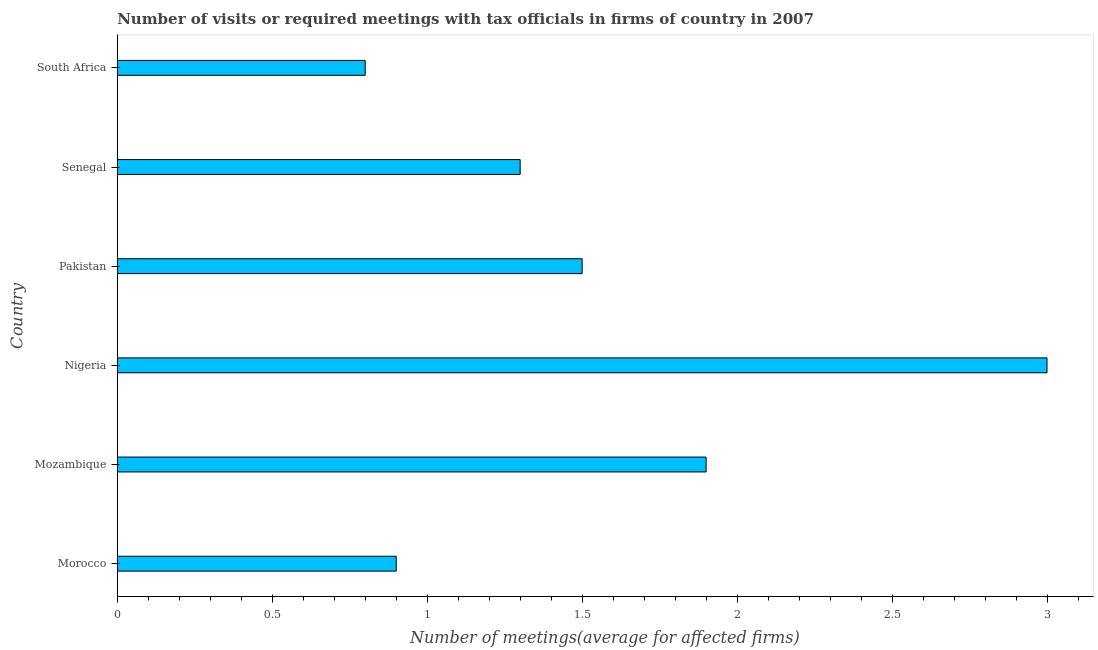Does the graph contain any zero values?
Your answer should be compact. No. Does the graph contain grids?
Provide a succinct answer. No. What is the title of the graph?
Your response must be concise. Number of visits or required meetings with tax officials in firms of country in 2007. What is the label or title of the X-axis?
Provide a succinct answer. Number of meetings(average for affected firms). What is the number of required meetings with tax officials in Morocco?
Give a very brief answer. 0.9. Across all countries, what is the maximum number of required meetings with tax officials?
Your answer should be very brief. 3. In which country was the number of required meetings with tax officials maximum?
Your answer should be compact. Nigeria. In which country was the number of required meetings with tax officials minimum?
Offer a very short reply. South Africa. What is the difference between the number of required meetings with tax officials in Mozambique and Senegal?
Provide a short and direct response. 0.6. What is the average number of required meetings with tax officials per country?
Provide a succinct answer. 1.57. What is the median number of required meetings with tax officials?
Provide a succinct answer. 1.4. In how many countries, is the number of required meetings with tax officials greater than 1.5 ?
Make the answer very short. 2. What is the ratio of the number of required meetings with tax officials in Mozambique to that in Pakistan?
Offer a terse response. 1.27. Is the number of required meetings with tax officials in Mozambique less than that in Pakistan?
Keep it short and to the point. No. In how many countries, is the number of required meetings with tax officials greater than the average number of required meetings with tax officials taken over all countries?
Offer a very short reply. 2. Are all the bars in the graph horizontal?
Make the answer very short. Yes. How many countries are there in the graph?
Ensure brevity in your answer.  6. What is the difference between two consecutive major ticks on the X-axis?
Offer a very short reply. 0.5. What is the Number of meetings(average for affected firms) in Pakistan?
Offer a terse response. 1.5. What is the Number of meetings(average for affected firms) in South Africa?
Ensure brevity in your answer.  0.8. What is the difference between the Number of meetings(average for affected firms) in Morocco and Nigeria?
Your answer should be very brief. -2.1. What is the difference between the Number of meetings(average for affected firms) in Morocco and Pakistan?
Make the answer very short. -0.6. What is the difference between the Number of meetings(average for affected firms) in Morocco and Senegal?
Keep it short and to the point. -0.4. What is the difference between the Number of meetings(average for affected firms) in Mozambique and Nigeria?
Keep it short and to the point. -1.1. What is the difference between the Number of meetings(average for affected firms) in Mozambique and South Africa?
Keep it short and to the point. 1.1. What is the difference between the Number of meetings(average for affected firms) in Nigeria and Pakistan?
Provide a short and direct response. 1.5. What is the difference between the Number of meetings(average for affected firms) in Nigeria and Senegal?
Give a very brief answer. 1.7. What is the difference between the Number of meetings(average for affected firms) in Senegal and South Africa?
Ensure brevity in your answer.  0.5. What is the ratio of the Number of meetings(average for affected firms) in Morocco to that in Mozambique?
Your answer should be very brief. 0.47. What is the ratio of the Number of meetings(average for affected firms) in Morocco to that in Nigeria?
Your response must be concise. 0.3. What is the ratio of the Number of meetings(average for affected firms) in Morocco to that in Senegal?
Give a very brief answer. 0.69. What is the ratio of the Number of meetings(average for affected firms) in Morocco to that in South Africa?
Make the answer very short. 1.12. What is the ratio of the Number of meetings(average for affected firms) in Mozambique to that in Nigeria?
Keep it short and to the point. 0.63. What is the ratio of the Number of meetings(average for affected firms) in Mozambique to that in Pakistan?
Give a very brief answer. 1.27. What is the ratio of the Number of meetings(average for affected firms) in Mozambique to that in Senegal?
Keep it short and to the point. 1.46. What is the ratio of the Number of meetings(average for affected firms) in Mozambique to that in South Africa?
Give a very brief answer. 2.38. What is the ratio of the Number of meetings(average for affected firms) in Nigeria to that in Pakistan?
Provide a succinct answer. 2. What is the ratio of the Number of meetings(average for affected firms) in Nigeria to that in Senegal?
Your answer should be very brief. 2.31. What is the ratio of the Number of meetings(average for affected firms) in Nigeria to that in South Africa?
Make the answer very short. 3.75. What is the ratio of the Number of meetings(average for affected firms) in Pakistan to that in Senegal?
Give a very brief answer. 1.15. What is the ratio of the Number of meetings(average for affected firms) in Pakistan to that in South Africa?
Provide a succinct answer. 1.88. What is the ratio of the Number of meetings(average for affected firms) in Senegal to that in South Africa?
Give a very brief answer. 1.62. 